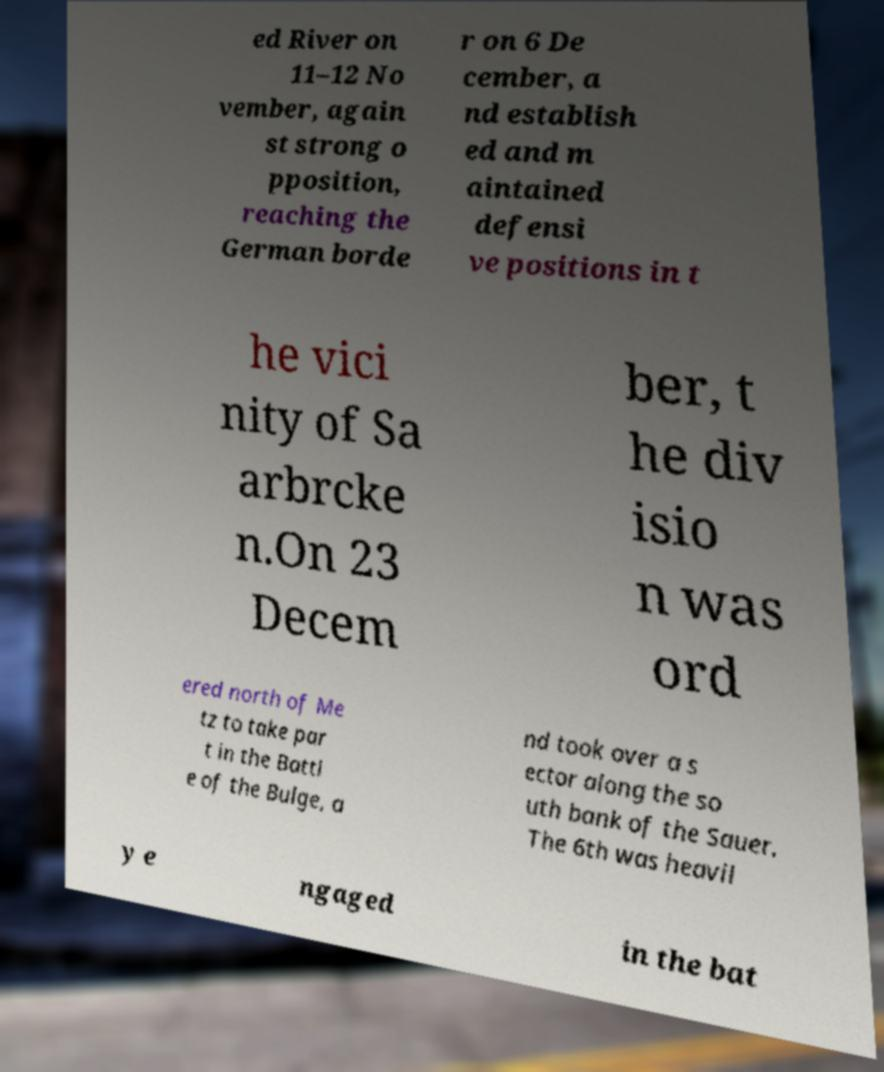There's text embedded in this image that I need extracted. Can you transcribe it verbatim? ed River on 11–12 No vember, again st strong o pposition, reaching the German borde r on 6 De cember, a nd establish ed and m aintained defensi ve positions in t he vici nity of Sa arbrcke n.On 23 Decem ber, t he div isio n was ord ered north of Me tz to take par t in the Battl e of the Bulge, a nd took over a s ector along the so uth bank of the Sauer. The 6th was heavil y e ngaged in the bat 